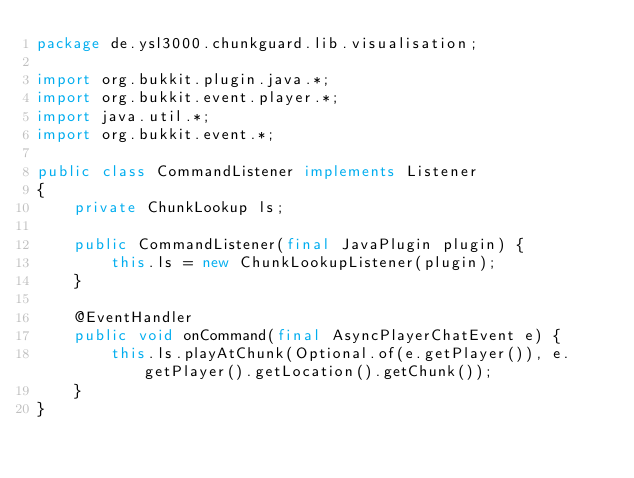Convert code to text. <code><loc_0><loc_0><loc_500><loc_500><_Java_>package de.ysl3000.chunkguard.lib.visualisation;

import org.bukkit.plugin.java.*;
import org.bukkit.event.player.*;
import java.util.*;
import org.bukkit.event.*;

public class CommandListener implements Listener
{
    private ChunkLookup ls;
    
    public CommandListener(final JavaPlugin plugin) {
        this.ls = new ChunkLookupListener(plugin);
    }
    
    @EventHandler
    public void onCommand(final AsyncPlayerChatEvent e) {
        this.ls.playAtChunk(Optional.of(e.getPlayer()), e.getPlayer().getLocation().getChunk());
    }
}
</code> 